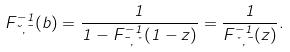Convert formula to latex. <formula><loc_0><loc_0><loc_500><loc_500>F ^ { - 1 } _ { \lambda , \mu } ( b ) = \frac { 1 } { 1 - F ^ { - 1 } _ { \mu , \nu } ( 1 - z ) } = \frac { 1 } { F ^ { - 1 } _ { \nu , \mu } ( z ) } .</formula> 